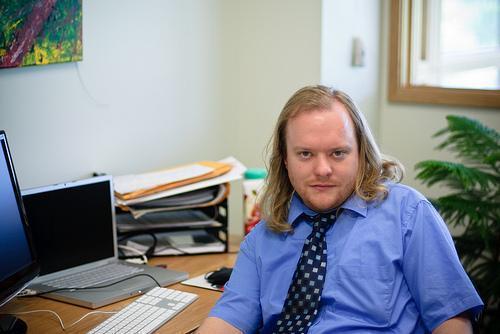How many men are pictured?
Give a very brief answer. 1. How many keyboards are shown?
Give a very brief answer. 2. 